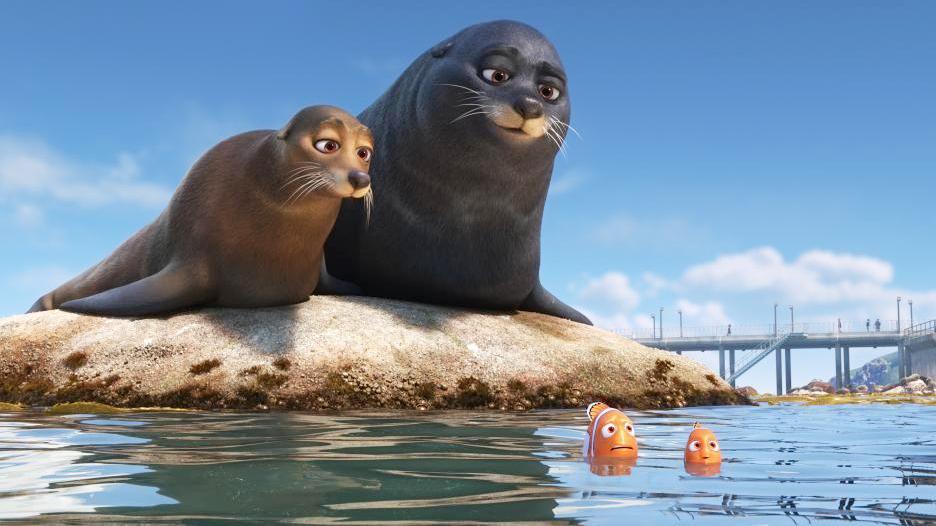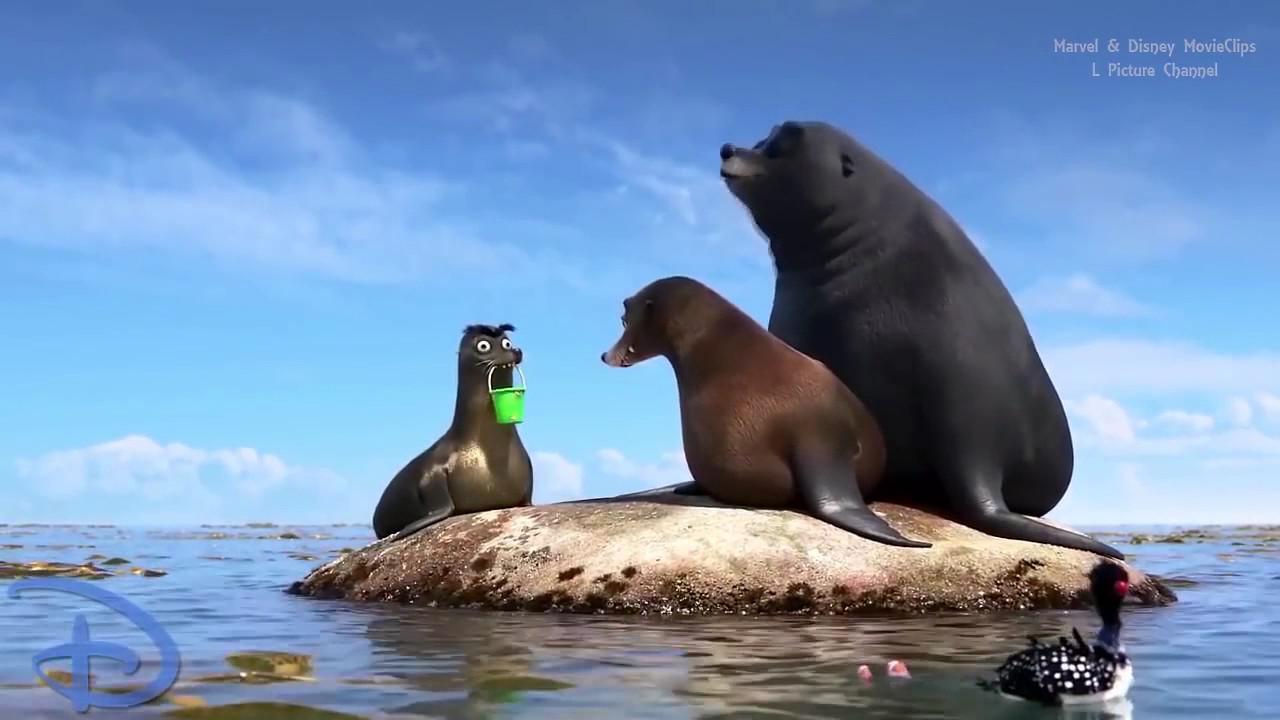The first image is the image on the left, the second image is the image on the right. Given the left and right images, does the statement "In one image, two seals are alone together on a small mound surrounded by water, and in the other image, a third seal has joined them on the mound." hold true? Answer yes or no. Yes. The first image is the image on the left, the second image is the image on the right. Examine the images to the left and right. Is the description "One image shoes three seals interacting with a small green bucket, and the other image shows two seals on a rock, one black and one brown." accurate? Answer yes or no. Yes. 